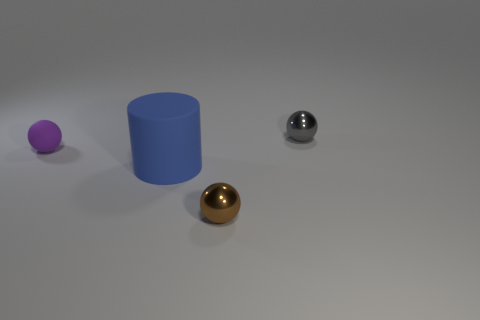Is there any other thing that has the same shape as the big blue object?
Keep it short and to the point. No. Does the object behind the tiny purple object have the same material as the blue cylinder?
Ensure brevity in your answer.  No. What number of small gray balls have the same material as the purple object?
Offer a terse response. 0. Are there more tiny matte spheres on the left side of the blue cylinder than big red metal spheres?
Your answer should be compact. Yes. Is there another tiny gray object of the same shape as the tiny rubber thing?
Offer a terse response. Yes. How many objects are brown metal objects or big yellow spheres?
Keep it short and to the point. 1. How many gray metallic balls are on the right side of the small shiny ball that is on the right side of the thing in front of the cylinder?
Keep it short and to the point. 0. There is a tiny purple thing that is the same shape as the brown thing; what material is it?
Provide a short and direct response. Rubber. What is the material of the small sphere that is both to the right of the big blue cylinder and behind the large blue rubber object?
Your response must be concise. Metal. Are there fewer small shiny things in front of the small rubber sphere than small spheres behind the brown metal ball?
Your response must be concise. Yes. 